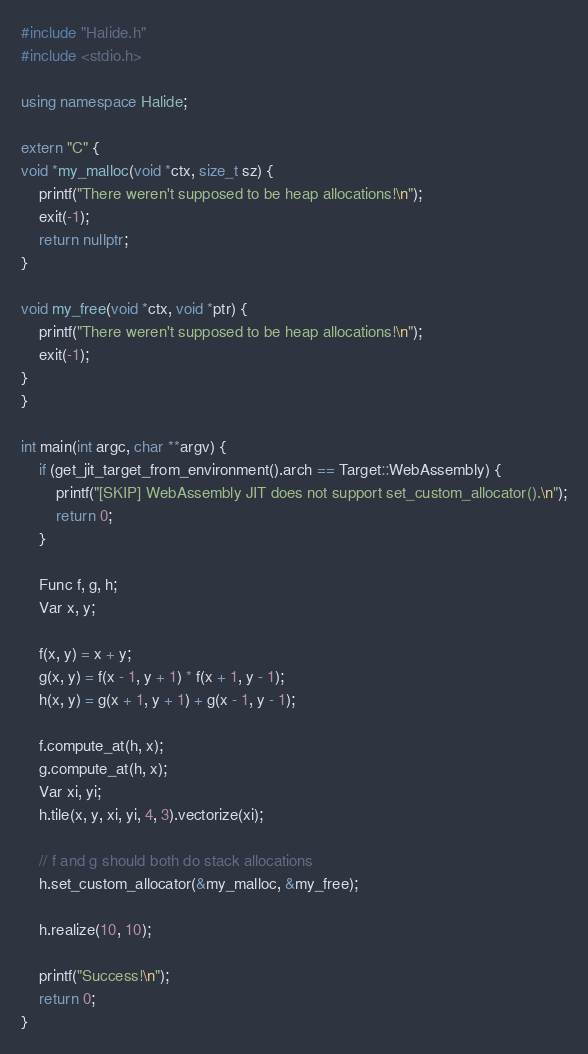Convert code to text. <code><loc_0><loc_0><loc_500><loc_500><_C++_>#include "Halide.h"
#include <stdio.h>

using namespace Halide;

extern "C" {
void *my_malloc(void *ctx, size_t sz) {
    printf("There weren't supposed to be heap allocations!\n");
    exit(-1);
    return nullptr;
}

void my_free(void *ctx, void *ptr) {
    printf("There weren't supposed to be heap allocations!\n");
    exit(-1);
}
}

int main(int argc, char **argv) {
    if (get_jit_target_from_environment().arch == Target::WebAssembly) {
        printf("[SKIP] WebAssembly JIT does not support set_custom_allocator().\n");
        return 0;
    }

    Func f, g, h;
    Var x, y;

    f(x, y) = x + y;
    g(x, y) = f(x - 1, y + 1) * f(x + 1, y - 1);
    h(x, y) = g(x + 1, y + 1) + g(x - 1, y - 1);

    f.compute_at(h, x);
    g.compute_at(h, x);
    Var xi, yi;
    h.tile(x, y, xi, yi, 4, 3).vectorize(xi);

    // f and g should both do stack allocations
    h.set_custom_allocator(&my_malloc, &my_free);

    h.realize(10, 10);

    printf("Success!\n");
    return 0;
}
</code> 